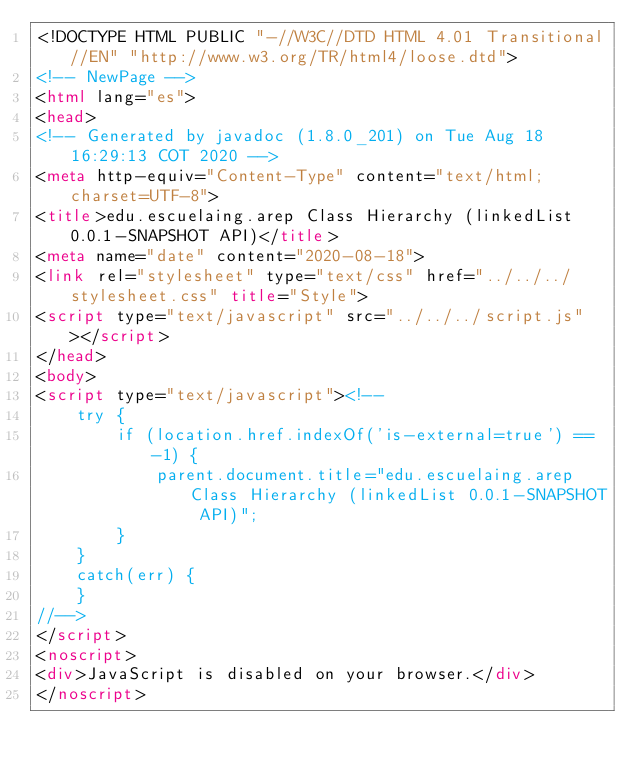<code> <loc_0><loc_0><loc_500><loc_500><_HTML_><!DOCTYPE HTML PUBLIC "-//W3C//DTD HTML 4.01 Transitional//EN" "http://www.w3.org/TR/html4/loose.dtd">
<!-- NewPage -->
<html lang="es">
<head>
<!-- Generated by javadoc (1.8.0_201) on Tue Aug 18 16:29:13 COT 2020 -->
<meta http-equiv="Content-Type" content="text/html; charset=UTF-8">
<title>edu.escuelaing.arep Class Hierarchy (linkedList 0.0.1-SNAPSHOT API)</title>
<meta name="date" content="2020-08-18">
<link rel="stylesheet" type="text/css" href="../../../stylesheet.css" title="Style">
<script type="text/javascript" src="../../../script.js"></script>
</head>
<body>
<script type="text/javascript"><!--
    try {
        if (location.href.indexOf('is-external=true') == -1) {
            parent.document.title="edu.escuelaing.arep Class Hierarchy (linkedList 0.0.1-SNAPSHOT API)";
        }
    }
    catch(err) {
    }
//-->
</script>
<noscript>
<div>JavaScript is disabled on your browser.</div>
</noscript></code> 